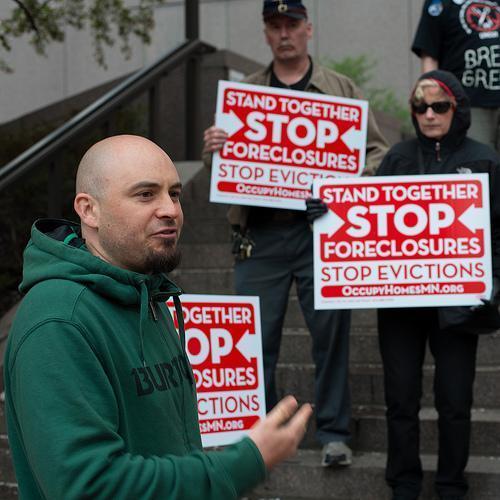How many people are being shown?
Give a very brief answer. 4. How many people are holding signs?
Give a very brief answer. 2. 